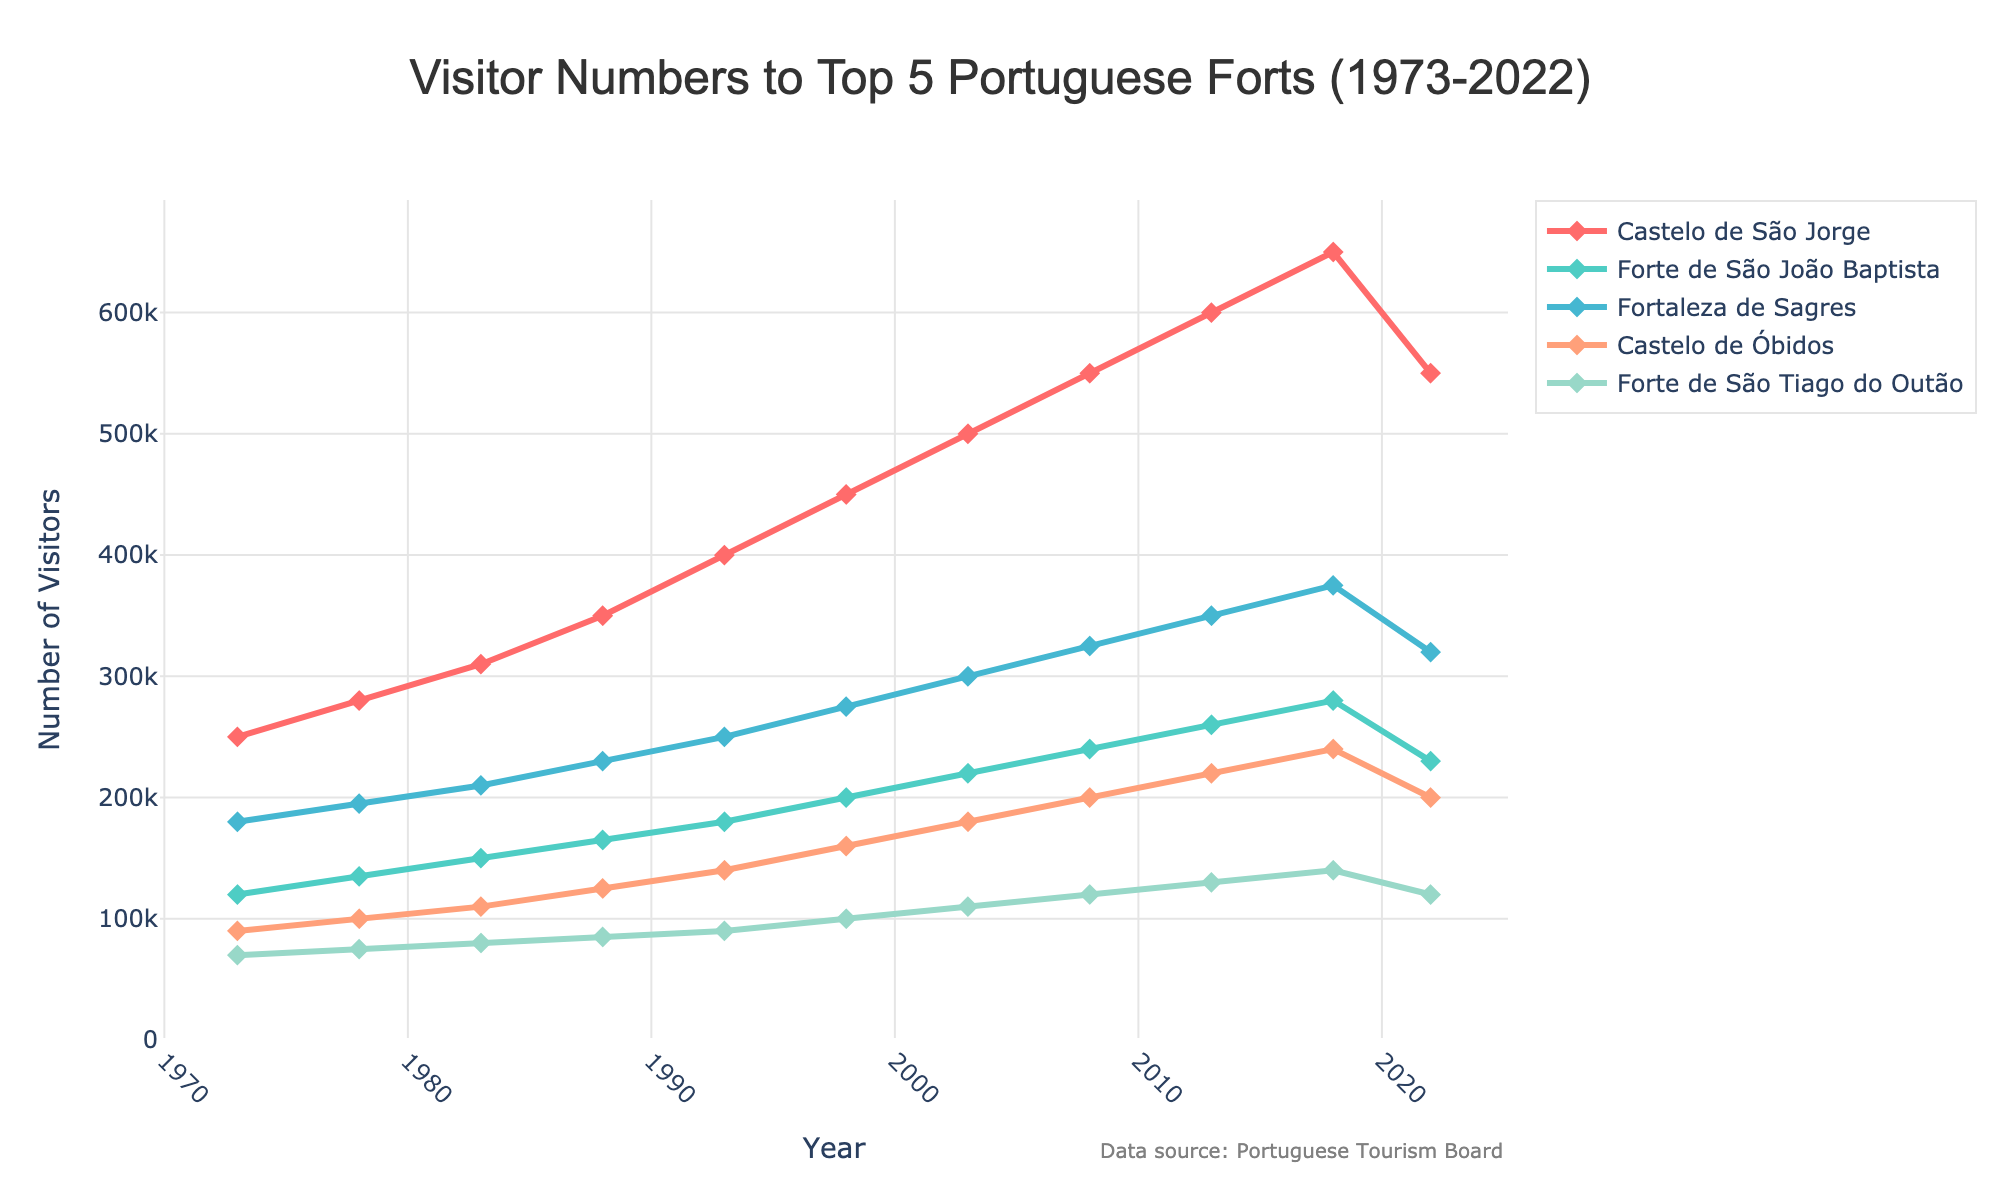What's the trend of visitor numbers to Castelo de São Jorge from 1973 to 2022? From 1973 to 2018, visitor numbers to Castelo de São Jorge generally increased, peaking at 650,000 in 2018. However, from 2018 to 2022, the numbers decreased to 550,000.
Answer: Increasing until 2018, then decreasing Which fort saw the highest number of visitors in 2022? By comparing the visitor numbers for each fort in 2022, Castelo de São Jorge had the highest number with 550,000 visitors.
Answer: Castelo de São Jorge What's the difference in visitor numbers between Castelo de São Jorge and Fortaleza de Sagres in 2022? In 2022, visitor numbers for Castelo de São Jorge and Fortaleza de Sagres were 550,000 and 320,000 respectively. The difference is 550,000 - 320,000 = 230,000.
Answer: 230,000 Which fort had the smallest increase in visitor numbers from 1973 to 2022? By calculating the difference in visitor numbers between 1973 and 2022 for each fort, Forte de São Tiago do Outão had the smallest increase, going from 70,000 to 120,000 visitors. The increase is 50,000.
Answer: Forte de São Tiago do Outão How did visitor numbers to Forte de São João Baptista change from 2018 to 2022? Visitor numbers to Forte de São João Baptista decreased from 280,000 in 2018 to 230,000 in 2022, representing a decrease of 50,000 visitors.
Answer: Decreased Which fort had the most consistent growth over the 50-year period? By examining the trends, Castelo de Óbidos had a steady increase in visitor numbers over the 50-year period without major fluctuations, making it the most consistent.
Answer: Castelo de Óbidos What was the average number of visitors to Fortaleza de Sagres over the 50-year period? Sum the visitor numbers for Fortaleza de Sagres from 1973 to 2022 and divide by 11. (180,000 + 195,000 + 210,000 + 230,000 + 250,000 + 275,000 + 300,000 + 325,000 + 350,000 + 375,000 + 320,000) / 11 = 292,727.27
Answer: 292,727.27 Compare the visitor number trends of Forte de São Tiago do Outão and Castelo de Óbidos over the years. Both forts show an increase in visitor numbers. However, Castelo de Óbidos shows a more significant and steady increase from 90,000 to 240,000, whereas Forte de São Tiago do Outão increases more gradually from 70,000 to 120,000.
Answer: Castelo de Óbidos had a more significant increase Which fort experienced a peak in the number of visitors in 2018? By looking at the visitor numbers in 2018, all forts except Castel de São Jorge reached their highest visitor numbers during this year.
Answer: All except Castelo de São Jorge 